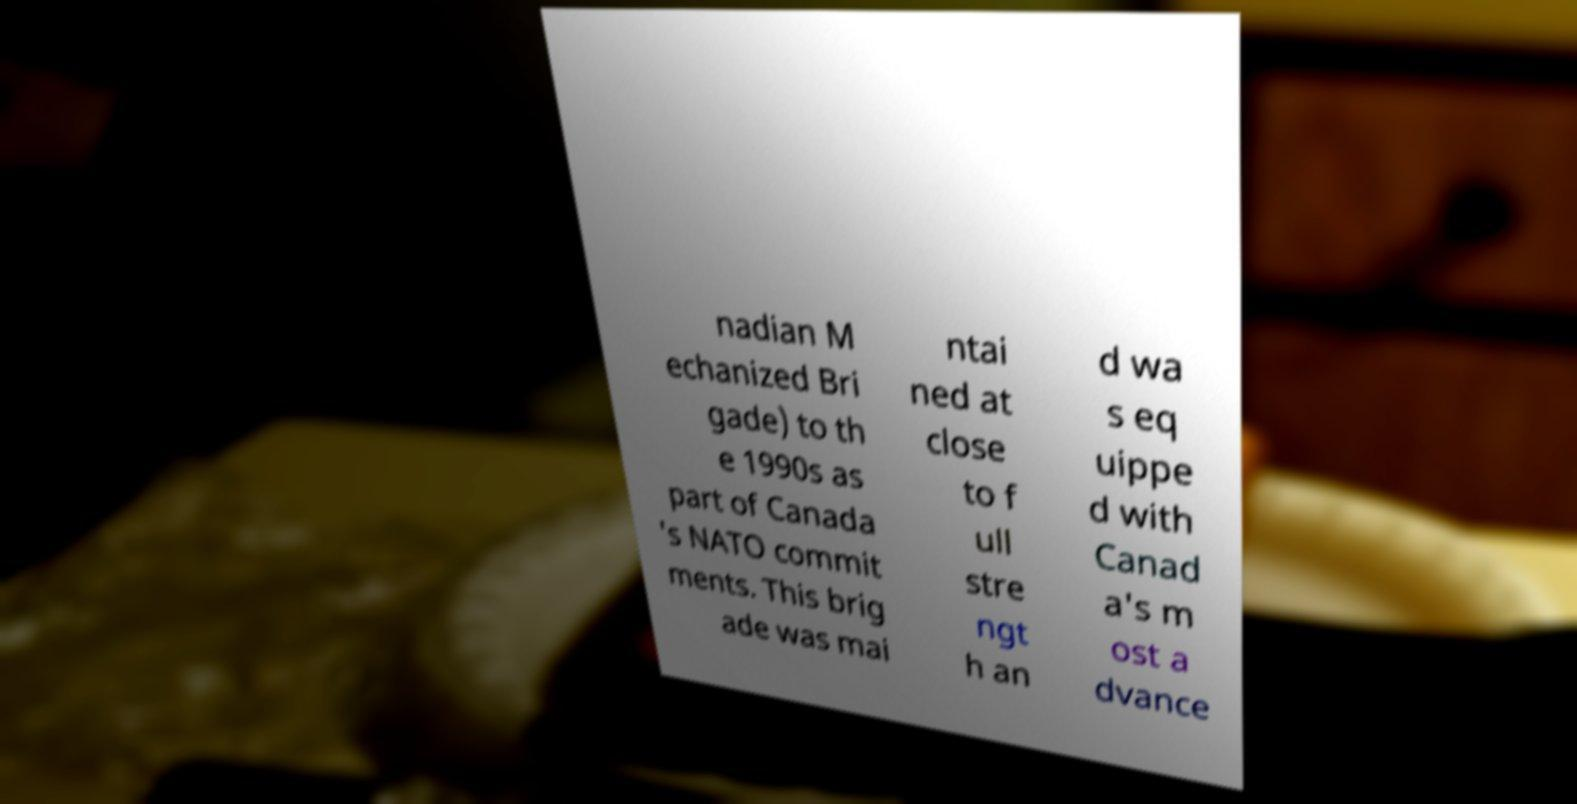For documentation purposes, I need the text within this image transcribed. Could you provide that? nadian M echanized Bri gade) to th e 1990s as part of Canada 's NATO commit ments. This brig ade was mai ntai ned at close to f ull stre ngt h an d wa s eq uippe d with Canad a's m ost a dvance 